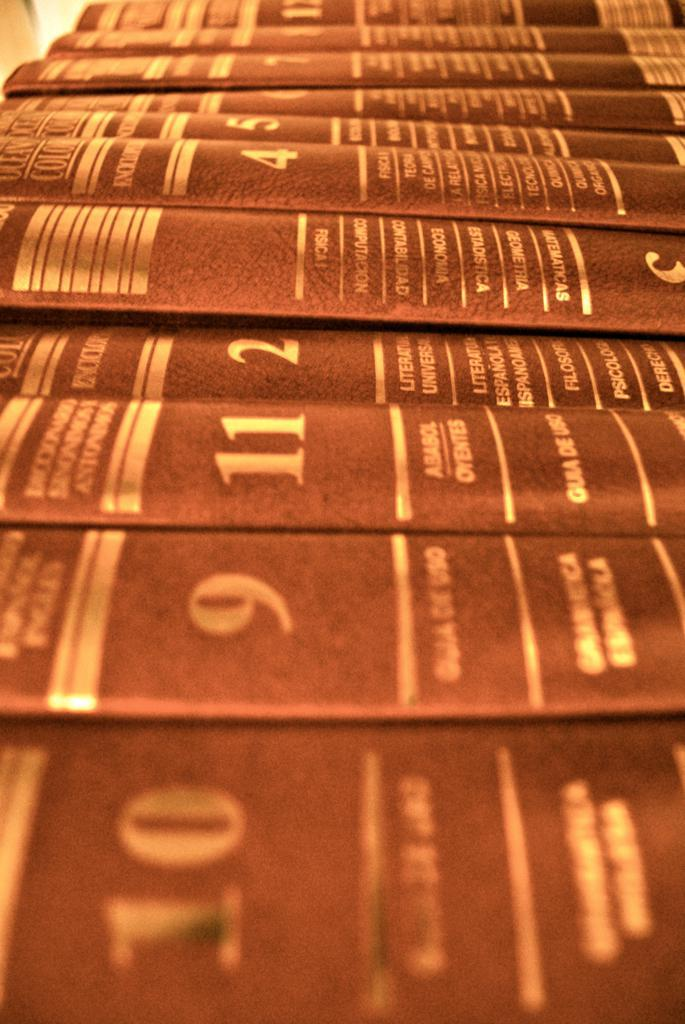Provide a one-sentence caption for the provided image. A blurred and coloured image of a group of of encyclopedias seen sideways on. 